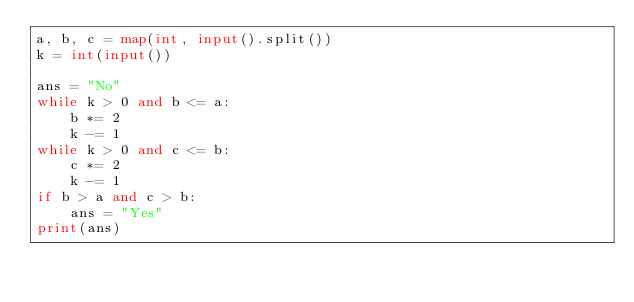Convert code to text. <code><loc_0><loc_0><loc_500><loc_500><_Python_>a, b, c = map(int, input().split())
k = int(input())

ans = "No"
while k > 0 and b <= a:
    b *= 2
    k -= 1
while k > 0 and c <= b:
    c *= 2
    k -= 1
if b > a and c > b:
    ans = "Yes"
print(ans)
</code> 